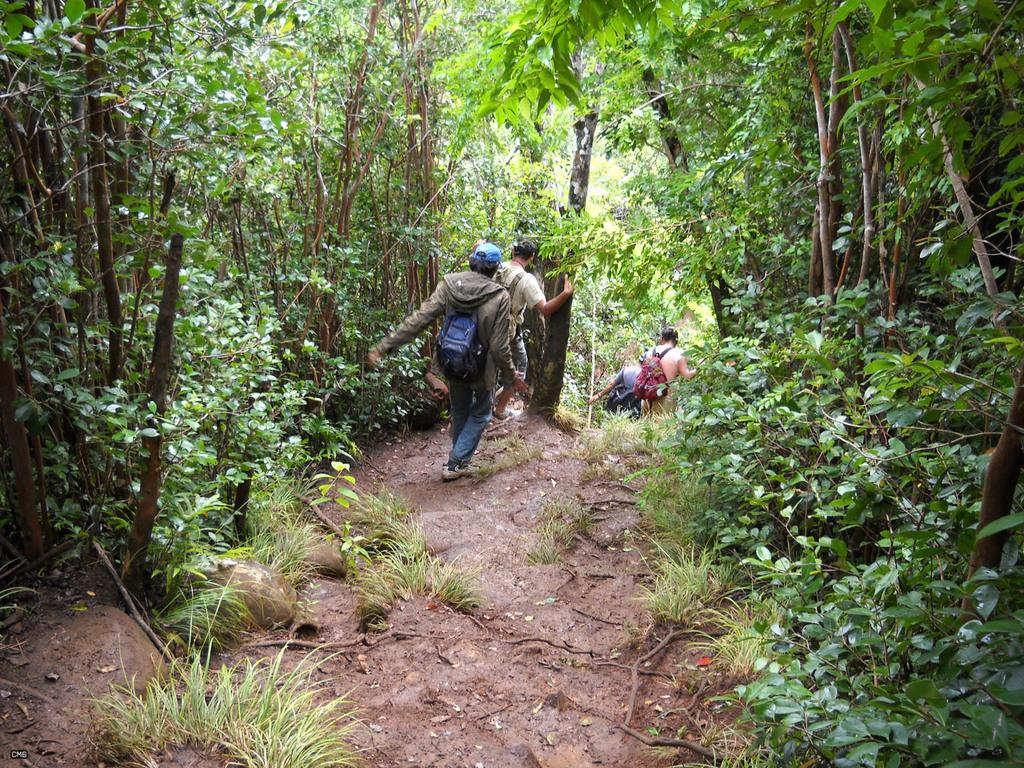Who or what can be seen in the image? There are people in the image. What is on the ground in the image? There are plants on the ground in the image. What can be seen in the distance in the image? There are trees visible in the background of the image. What type of hole can be seen in the image? There is no hole present in the image. 